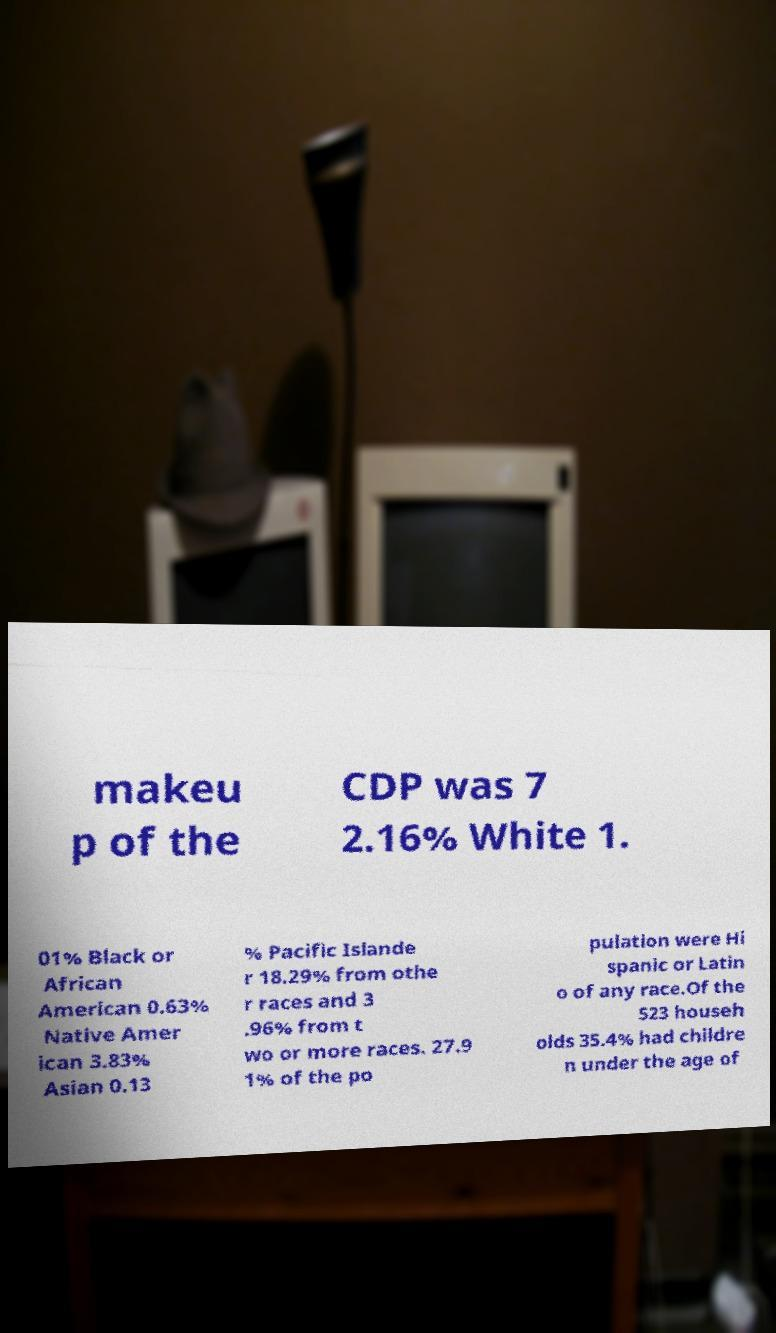Could you assist in decoding the text presented in this image and type it out clearly? makeu p of the CDP was 7 2.16% White 1. 01% Black or African American 0.63% Native Amer ican 3.83% Asian 0.13 % Pacific Islande r 18.29% from othe r races and 3 .96% from t wo or more races. 27.9 1% of the po pulation were Hi spanic or Latin o of any race.Of the 523 househ olds 35.4% had childre n under the age of 